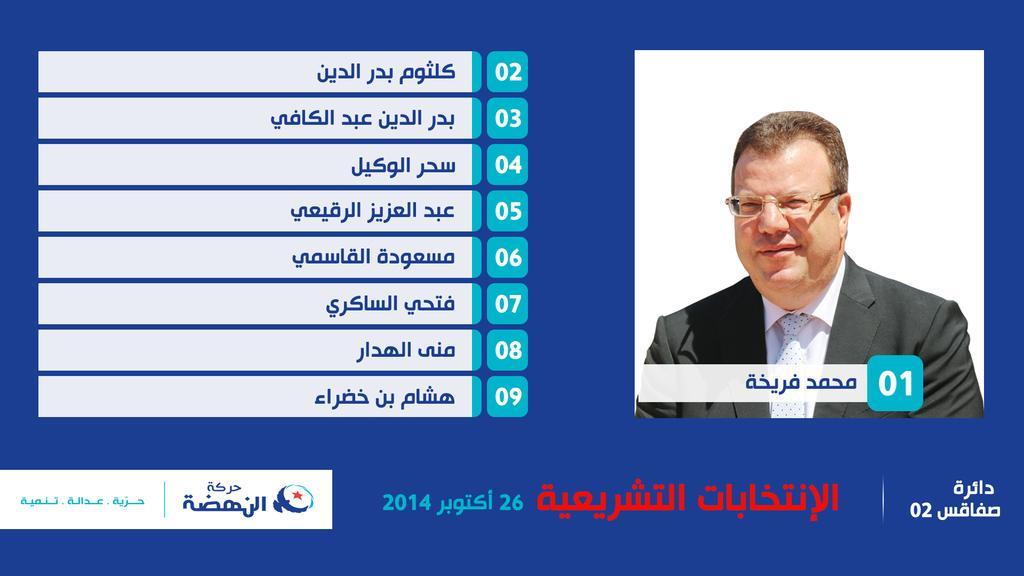Can you describe this image briefly? In this image i can see a person image at the right side. He is wearing suit, tie and spectacles. Left side there is some text. Background is in blue color. 